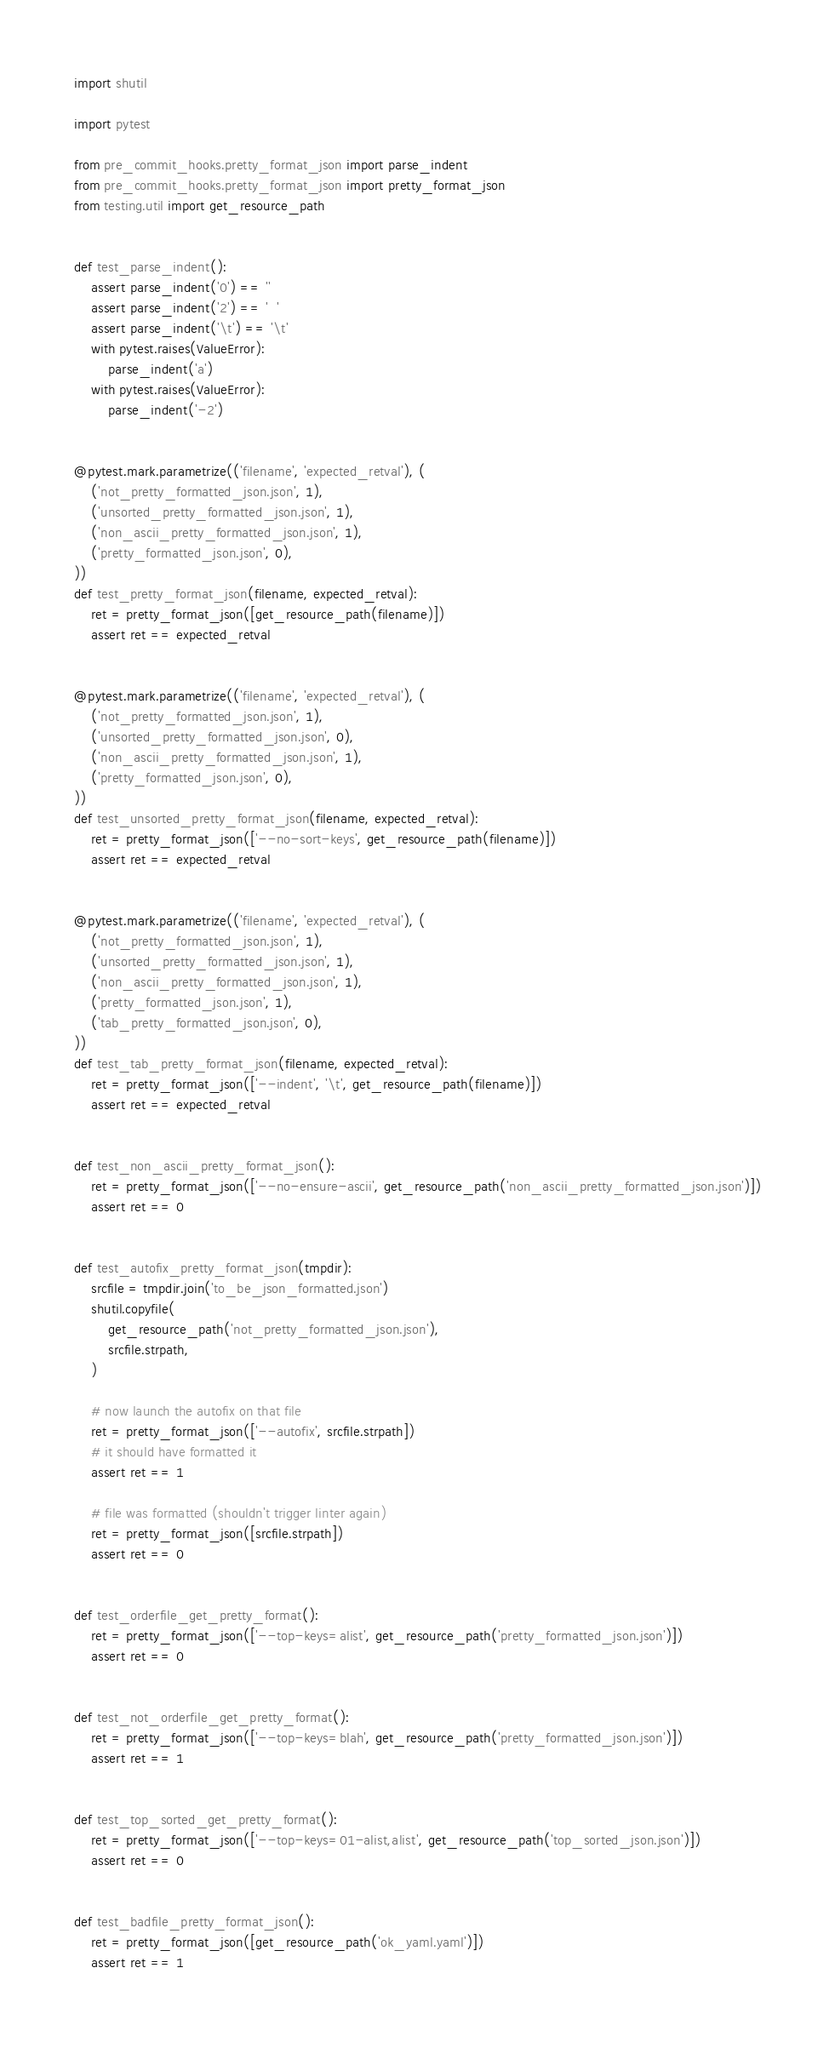<code> <loc_0><loc_0><loc_500><loc_500><_Python_>import shutil

import pytest

from pre_commit_hooks.pretty_format_json import parse_indent
from pre_commit_hooks.pretty_format_json import pretty_format_json
from testing.util import get_resource_path


def test_parse_indent():
    assert parse_indent('0') == ''
    assert parse_indent('2') == '  '
    assert parse_indent('\t') == '\t'
    with pytest.raises(ValueError):
        parse_indent('a')
    with pytest.raises(ValueError):
        parse_indent('-2')


@pytest.mark.parametrize(('filename', 'expected_retval'), (
    ('not_pretty_formatted_json.json', 1),
    ('unsorted_pretty_formatted_json.json', 1),
    ('non_ascii_pretty_formatted_json.json', 1),
    ('pretty_formatted_json.json', 0),
))
def test_pretty_format_json(filename, expected_retval):
    ret = pretty_format_json([get_resource_path(filename)])
    assert ret == expected_retval


@pytest.mark.parametrize(('filename', 'expected_retval'), (
    ('not_pretty_formatted_json.json', 1),
    ('unsorted_pretty_formatted_json.json', 0),
    ('non_ascii_pretty_formatted_json.json', 1),
    ('pretty_formatted_json.json', 0),
))
def test_unsorted_pretty_format_json(filename, expected_retval):
    ret = pretty_format_json(['--no-sort-keys', get_resource_path(filename)])
    assert ret == expected_retval


@pytest.mark.parametrize(('filename', 'expected_retval'), (
    ('not_pretty_formatted_json.json', 1),
    ('unsorted_pretty_formatted_json.json', 1),
    ('non_ascii_pretty_formatted_json.json', 1),
    ('pretty_formatted_json.json', 1),
    ('tab_pretty_formatted_json.json', 0),
))
def test_tab_pretty_format_json(filename, expected_retval):
    ret = pretty_format_json(['--indent', '\t', get_resource_path(filename)])
    assert ret == expected_retval


def test_non_ascii_pretty_format_json():
    ret = pretty_format_json(['--no-ensure-ascii', get_resource_path('non_ascii_pretty_formatted_json.json')])
    assert ret == 0


def test_autofix_pretty_format_json(tmpdir):
    srcfile = tmpdir.join('to_be_json_formatted.json')
    shutil.copyfile(
        get_resource_path('not_pretty_formatted_json.json'),
        srcfile.strpath,
    )

    # now launch the autofix on that file
    ret = pretty_format_json(['--autofix', srcfile.strpath])
    # it should have formatted it
    assert ret == 1

    # file was formatted (shouldn't trigger linter again)
    ret = pretty_format_json([srcfile.strpath])
    assert ret == 0


def test_orderfile_get_pretty_format():
    ret = pretty_format_json(['--top-keys=alist', get_resource_path('pretty_formatted_json.json')])
    assert ret == 0


def test_not_orderfile_get_pretty_format():
    ret = pretty_format_json(['--top-keys=blah', get_resource_path('pretty_formatted_json.json')])
    assert ret == 1


def test_top_sorted_get_pretty_format():
    ret = pretty_format_json(['--top-keys=01-alist,alist', get_resource_path('top_sorted_json.json')])
    assert ret == 0


def test_badfile_pretty_format_json():
    ret = pretty_format_json([get_resource_path('ok_yaml.yaml')])
    assert ret == 1
</code> 